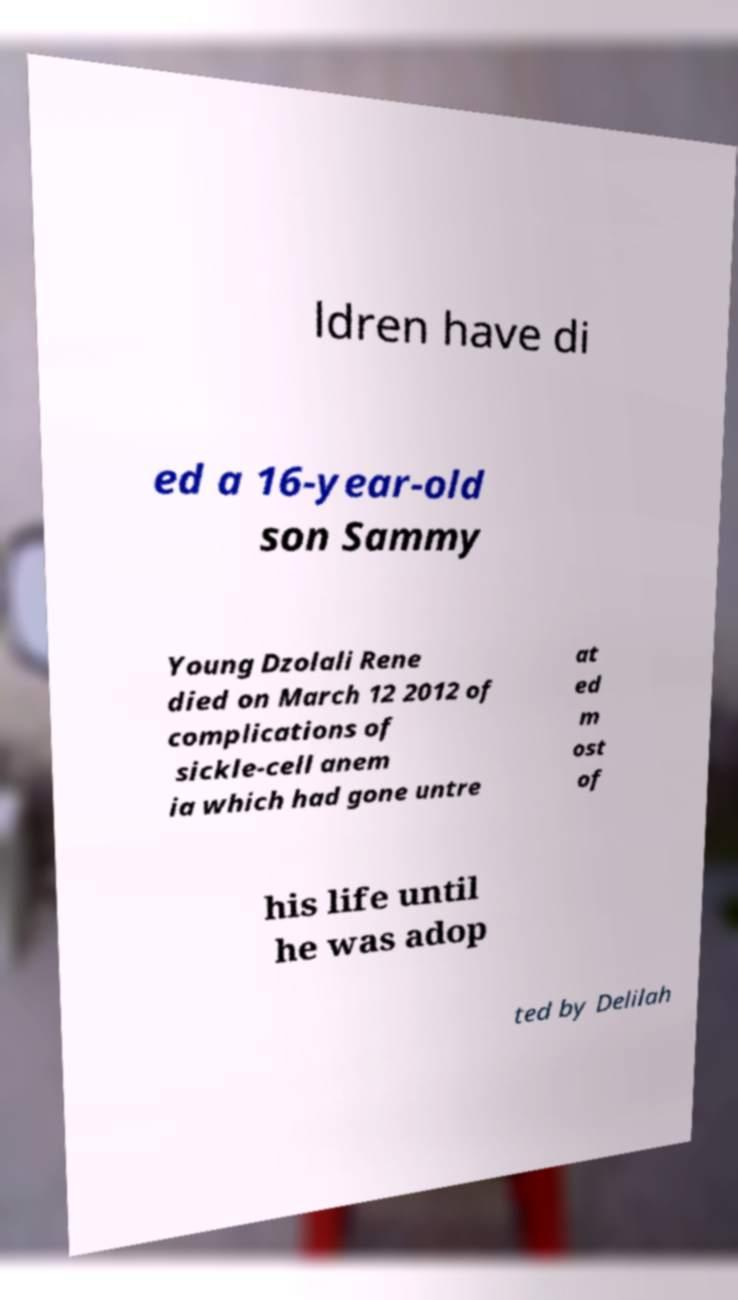Could you assist in decoding the text presented in this image and type it out clearly? ldren have di ed a 16-year-old son Sammy Young Dzolali Rene died on March 12 2012 of complications of sickle-cell anem ia which had gone untre at ed m ost of his life until he was adop ted by Delilah 